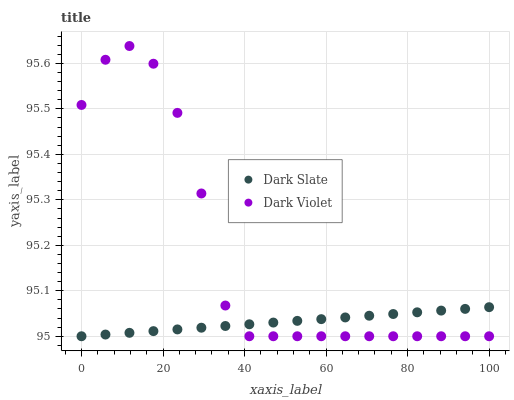Does Dark Slate have the minimum area under the curve?
Answer yes or no. Yes. Does Dark Violet have the maximum area under the curve?
Answer yes or no. Yes. Does Dark Violet have the minimum area under the curve?
Answer yes or no. No. Is Dark Slate the smoothest?
Answer yes or no. Yes. Is Dark Violet the roughest?
Answer yes or no. Yes. Is Dark Violet the smoothest?
Answer yes or no. No. Does Dark Slate have the lowest value?
Answer yes or no. Yes. Does Dark Violet have the highest value?
Answer yes or no. Yes. Does Dark Violet intersect Dark Slate?
Answer yes or no. Yes. Is Dark Violet less than Dark Slate?
Answer yes or no. No. Is Dark Violet greater than Dark Slate?
Answer yes or no. No. 